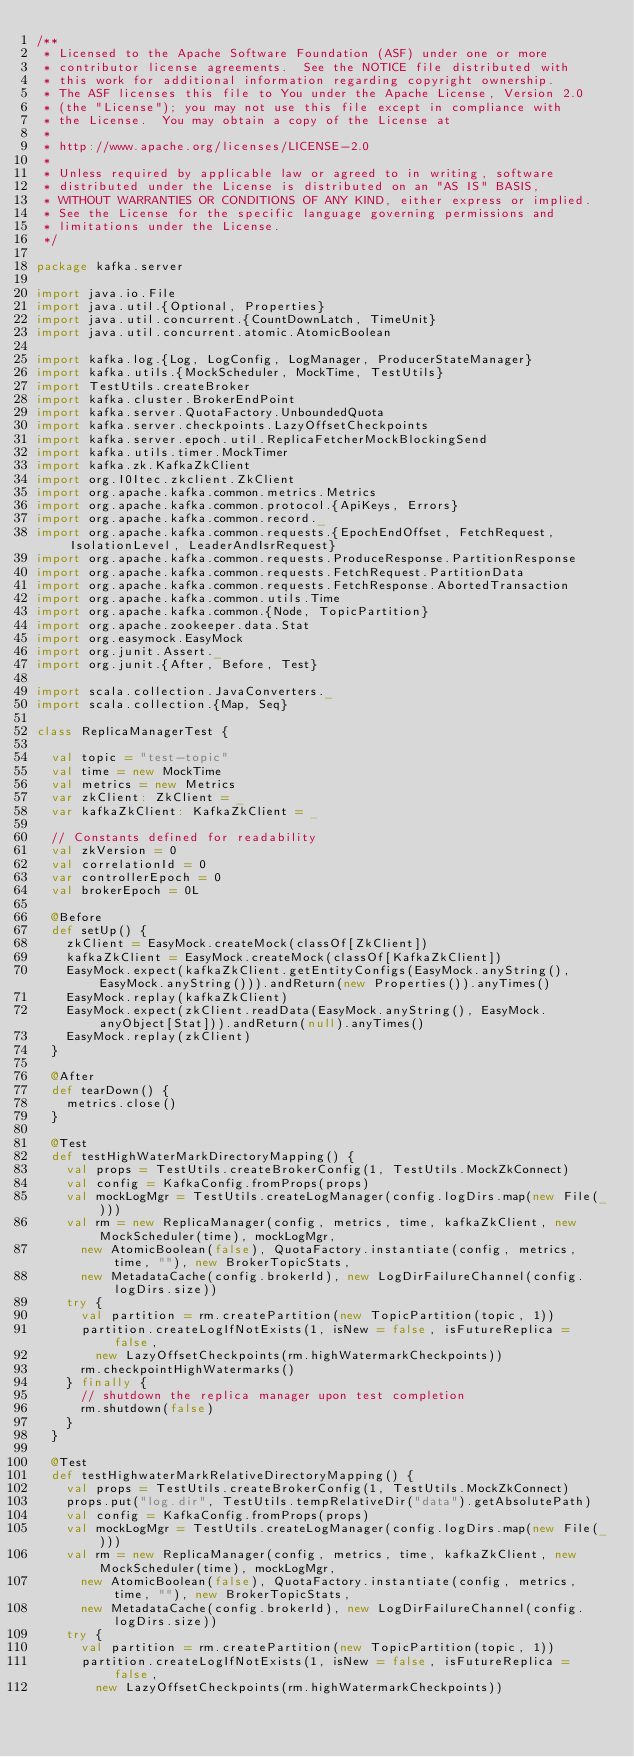<code> <loc_0><loc_0><loc_500><loc_500><_Scala_>/**
 * Licensed to the Apache Software Foundation (ASF) under one or more
 * contributor license agreements.  See the NOTICE file distributed with
 * this work for additional information regarding copyright ownership.
 * The ASF licenses this file to You under the Apache License, Version 2.0
 * (the "License"); you may not use this file except in compliance with
 * the License.  You may obtain a copy of the License at
 *
 * http://www.apache.org/licenses/LICENSE-2.0
 *
 * Unless required by applicable law or agreed to in writing, software
 * distributed under the License is distributed on an "AS IS" BASIS,
 * WITHOUT WARRANTIES OR CONDITIONS OF ANY KIND, either express or implied.
 * See the License for the specific language governing permissions and
 * limitations under the License.
 */

package kafka.server

import java.io.File
import java.util.{Optional, Properties}
import java.util.concurrent.{CountDownLatch, TimeUnit}
import java.util.concurrent.atomic.AtomicBoolean

import kafka.log.{Log, LogConfig, LogManager, ProducerStateManager}
import kafka.utils.{MockScheduler, MockTime, TestUtils}
import TestUtils.createBroker
import kafka.cluster.BrokerEndPoint
import kafka.server.QuotaFactory.UnboundedQuota
import kafka.server.checkpoints.LazyOffsetCheckpoints
import kafka.server.epoch.util.ReplicaFetcherMockBlockingSend
import kafka.utils.timer.MockTimer
import kafka.zk.KafkaZkClient
import org.I0Itec.zkclient.ZkClient
import org.apache.kafka.common.metrics.Metrics
import org.apache.kafka.common.protocol.{ApiKeys, Errors}
import org.apache.kafka.common.record._
import org.apache.kafka.common.requests.{EpochEndOffset, FetchRequest, IsolationLevel, LeaderAndIsrRequest}
import org.apache.kafka.common.requests.ProduceResponse.PartitionResponse
import org.apache.kafka.common.requests.FetchRequest.PartitionData
import org.apache.kafka.common.requests.FetchResponse.AbortedTransaction
import org.apache.kafka.common.utils.Time
import org.apache.kafka.common.{Node, TopicPartition}
import org.apache.zookeeper.data.Stat
import org.easymock.EasyMock
import org.junit.Assert._
import org.junit.{After, Before, Test}

import scala.collection.JavaConverters._
import scala.collection.{Map, Seq}

class ReplicaManagerTest {

  val topic = "test-topic"
  val time = new MockTime
  val metrics = new Metrics
  var zkClient: ZkClient = _
  var kafkaZkClient: KafkaZkClient = _

  // Constants defined for readability
  val zkVersion = 0
  val correlationId = 0
  var controllerEpoch = 0
  val brokerEpoch = 0L

  @Before
  def setUp() {
    zkClient = EasyMock.createMock(classOf[ZkClient])
    kafkaZkClient = EasyMock.createMock(classOf[KafkaZkClient])
    EasyMock.expect(kafkaZkClient.getEntityConfigs(EasyMock.anyString(), EasyMock.anyString())).andReturn(new Properties()).anyTimes()
    EasyMock.replay(kafkaZkClient)
    EasyMock.expect(zkClient.readData(EasyMock.anyString(), EasyMock.anyObject[Stat])).andReturn(null).anyTimes()
    EasyMock.replay(zkClient)
  }

  @After
  def tearDown() {
    metrics.close()
  }

  @Test
  def testHighWaterMarkDirectoryMapping() {
    val props = TestUtils.createBrokerConfig(1, TestUtils.MockZkConnect)
    val config = KafkaConfig.fromProps(props)
    val mockLogMgr = TestUtils.createLogManager(config.logDirs.map(new File(_)))
    val rm = new ReplicaManager(config, metrics, time, kafkaZkClient, new MockScheduler(time), mockLogMgr,
      new AtomicBoolean(false), QuotaFactory.instantiate(config, metrics, time, ""), new BrokerTopicStats,
      new MetadataCache(config.brokerId), new LogDirFailureChannel(config.logDirs.size))
    try {
      val partition = rm.createPartition(new TopicPartition(topic, 1))
      partition.createLogIfNotExists(1, isNew = false, isFutureReplica = false,
        new LazyOffsetCheckpoints(rm.highWatermarkCheckpoints))
      rm.checkpointHighWatermarks()
    } finally {
      // shutdown the replica manager upon test completion
      rm.shutdown(false)
    }
  }

  @Test
  def testHighwaterMarkRelativeDirectoryMapping() {
    val props = TestUtils.createBrokerConfig(1, TestUtils.MockZkConnect)
    props.put("log.dir", TestUtils.tempRelativeDir("data").getAbsolutePath)
    val config = KafkaConfig.fromProps(props)
    val mockLogMgr = TestUtils.createLogManager(config.logDirs.map(new File(_)))
    val rm = new ReplicaManager(config, metrics, time, kafkaZkClient, new MockScheduler(time), mockLogMgr,
      new AtomicBoolean(false), QuotaFactory.instantiate(config, metrics, time, ""), new BrokerTopicStats,
      new MetadataCache(config.brokerId), new LogDirFailureChannel(config.logDirs.size))
    try {
      val partition = rm.createPartition(new TopicPartition(topic, 1))
      partition.createLogIfNotExists(1, isNew = false, isFutureReplica = false,
        new LazyOffsetCheckpoints(rm.highWatermarkCheckpoints))</code> 